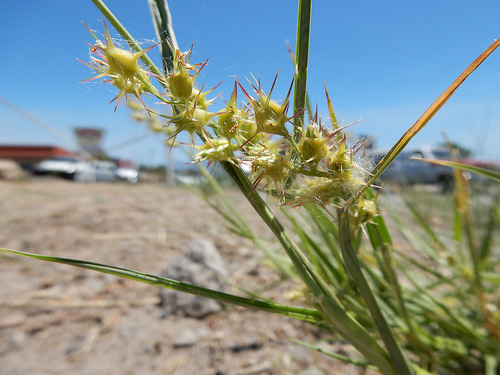<image>
Is the sky next to the plant? Yes. The sky is positioned adjacent to the plant, located nearby in the same general area. 